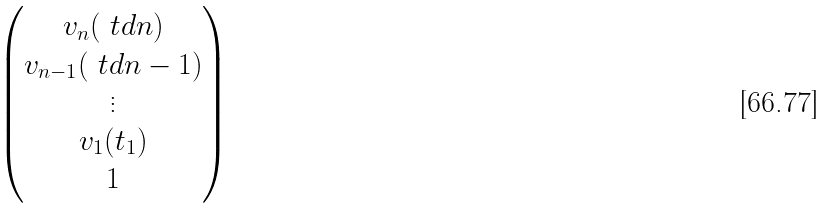Convert formula to latex. <formula><loc_0><loc_0><loc_500><loc_500>\begin{pmatrix} v _ { n } ( \ t d { n } ) \\ v _ { n - 1 } ( \ t d { n - 1 } ) \\ \vdots \\ v _ { 1 } ( t _ { 1 } ) \\ 1 \end{pmatrix}</formula> 